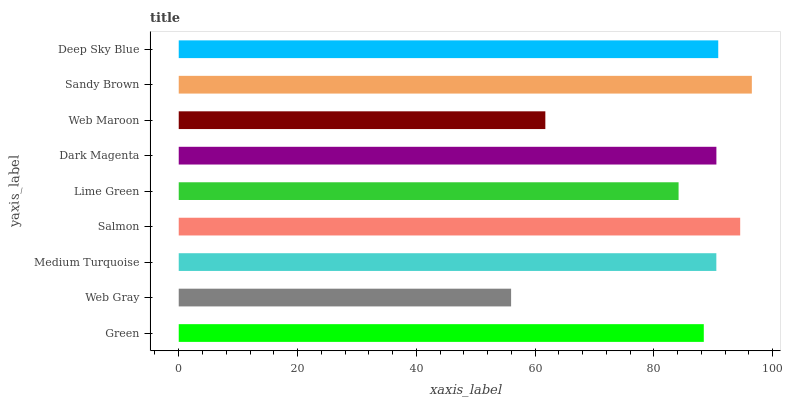Is Web Gray the minimum?
Answer yes or no. Yes. Is Sandy Brown the maximum?
Answer yes or no. Yes. Is Medium Turquoise the minimum?
Answer yes or no. No. Is Medium Turquoise the maximum?
Answer yes or no. No. Is Medium Turquoise greater than Web Gray?
Answer yes or no. Yes. Is Web Gray less than Medium Turquoise?
Answer yes or no. Yes. Is Web Gray greater than Medium Turquoise?
Answer yes or no. No. Is Medium Turquoise less than Web Gray?
Answer yes or no. No. Is Medium Turquoise the high median?
Answer yes or no. Yes. Is Medium Turquoise the low median?
Answer yes or no. Yes. Is Web Gray the high median?
Answer yes or no. No. Is Salmon the low median?
Answer yes or no. No. 